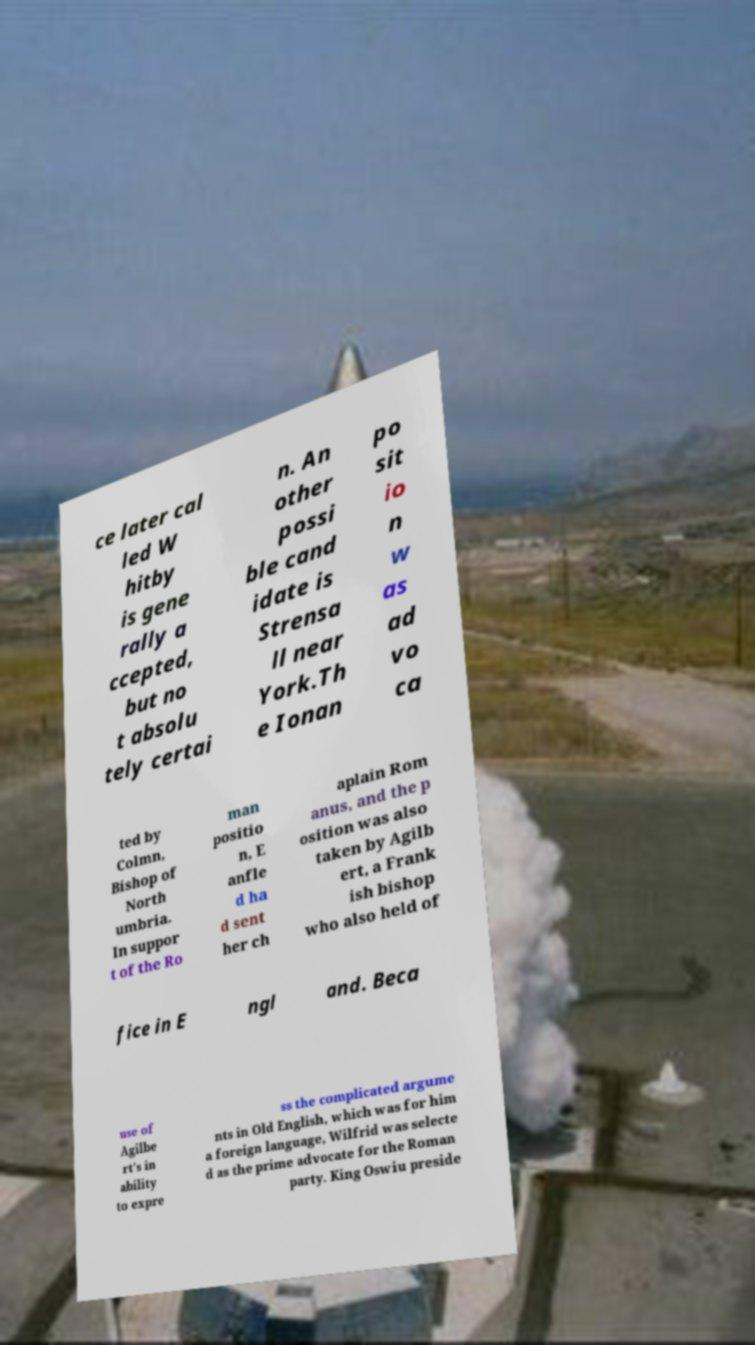Could you extract and type out the text from this image? ce later cal led W hitby is gene rally a ccepted, but no t absolu tely certai n. An other possi ble cand idate is Strensa ll near York.Th e Ionan po sit io n w as ad vo ca ted by Colmn, Bishop of North umbria. In suppor t of the Ro man positio n, E anfle d ha d sent her ch aplain Rom anus, and the p osition was also taken by Agilb ert, a Frank ish bishop who also held of fice in E ngl and. Beca use of Agilbe rt's in ability to expre ss the complicated argume nts in Old English, which was for him a foreign language, Wilfrid was selecte d as the prime advocate for the Roman party. King Oswiu preside 